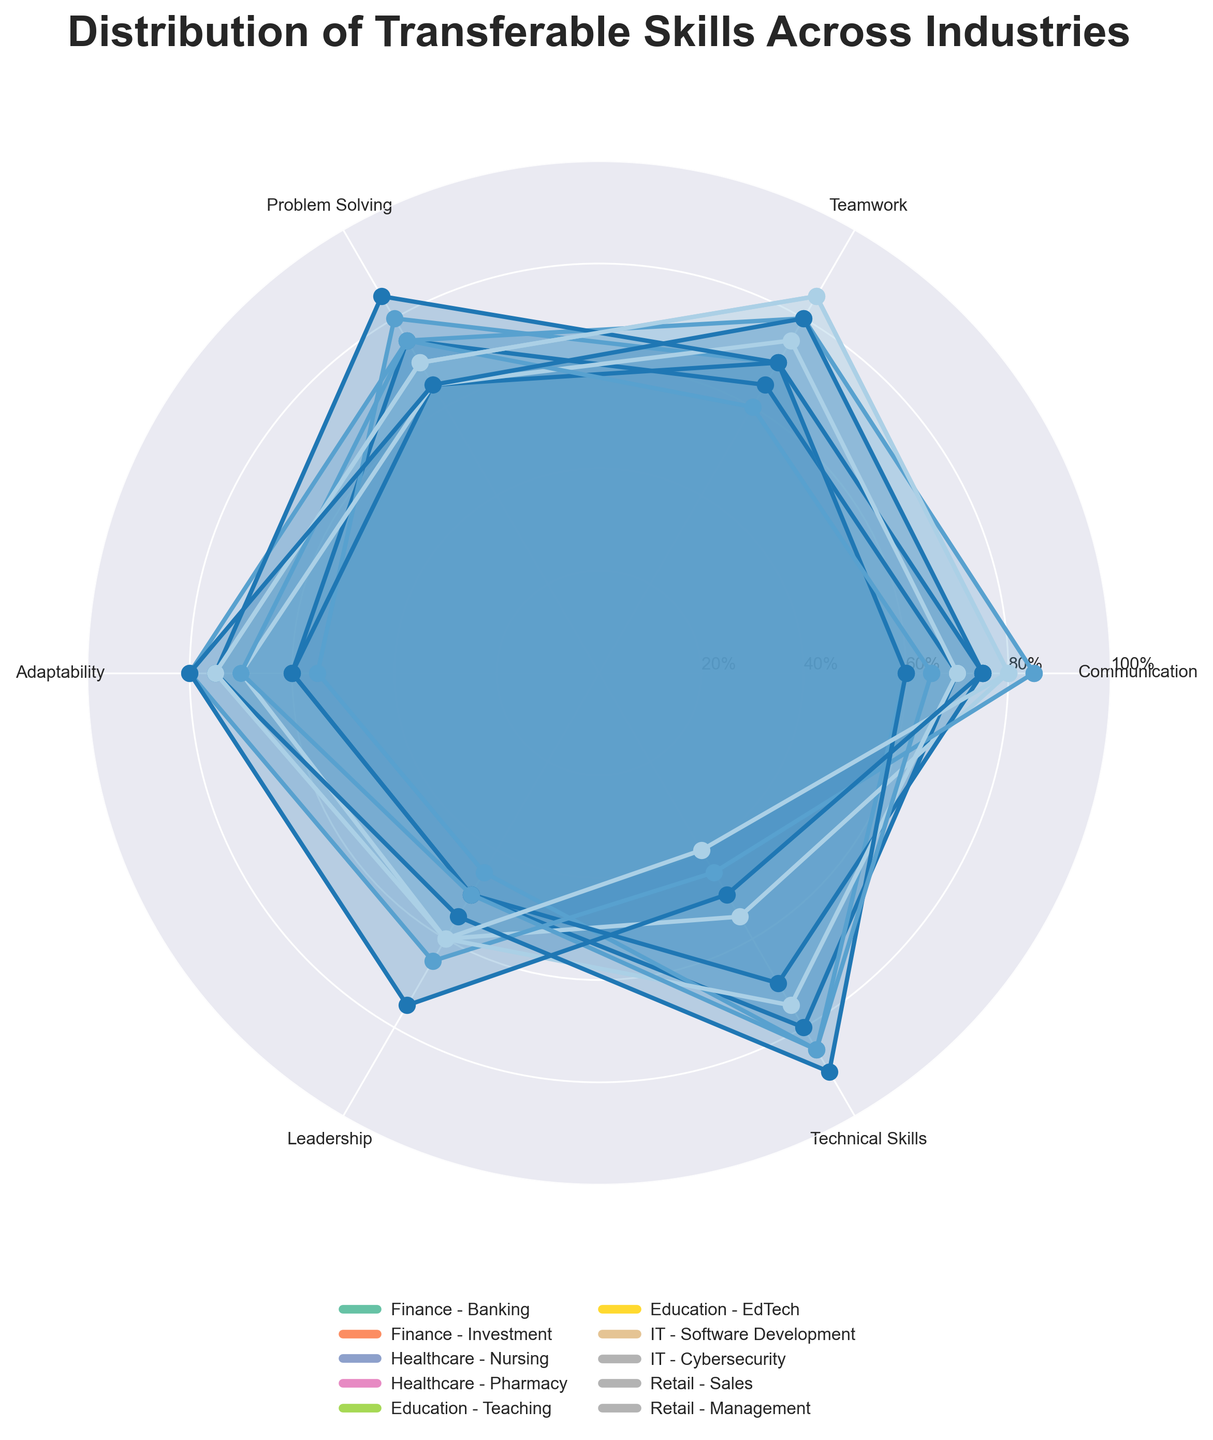How many industry sectors are depicted in the plot? The plot shows data from different sectors identified in the legend. Count the number of sectors listed in the legend.
Answer: 10 Which sector in the Finance industry has a higher value for Problem Solving? Compare the Problem Solving scores of the Banking and Investment sectors within the Finance industry depicted in the plot.
Answer: Investment What is the average Communication score across the sectors in the IT industry? Identify the Communication scores for Software Development and Cybersecurity from the plot. Sum these scores and divide by the number of sectors. (60+65)/2 = 125/2 = 62.5
Answer: 62.5 Which skill is most emphasized in the Healthcare industry? Compare the heights of the polar area segments for Nursing and Pharmacy sectors across all skills.
Answer: Teamwork Which sector among Education, Healthcare, and Retail generally has the lowest Technical Skills? For each listed industry, identify the sector with the lowest Technical Skills score by examining the plot.
Answer: Retail - Sales Which industry has the highest average Adaptability score? Calculate the average Adaptability score for each industry by summing the Adaptability scores of its sectors and dividing by the number of sectors. Compare these averages across all industries (Education: (80+70)/2=75, Healthcare: (75+60)/2=67.5, IT: (75+70)/2=72.5, Finance: (60+55)/2=57.5, Retail: (75+80)/2=77.5)
Answer: Retail Are Leadership values generally higher in the Education industry compared to the Finance industry? For both Education sectors, compare the Leadership values to those of both Finance sectors. Education Leadership: (65+60)/2 = 62.5; Finance Leadership: (50+45)/2 = 47.5
Answer: Yes Based on the plot, which sector has the most balanced distribution of skills? Look for a sector where the segments in the radial diagram appear to be of similar size, implying balanced skill distribution.
Answer: Nursing What percentage of skills in the Nursing sector is above 70%? Count the number of skills in Nursing with a score higher than 70% and divide by the total number of skills. Four skills (Communication, Teamwork, Adaptability, Leadership) are above 70%, out of six total skills. (4/6)*100 = 66.67%
Answer: 66.67% Which two skills have the largest difference in scores in the Management sector? Identify the scores for all skills in the Management sector, compute the pairwise differences, and determine the two skills with the highest difference. Leadership (75) and Technical Skills (50) have a difference of 25.
Answer: Leadership and Technical Skills 